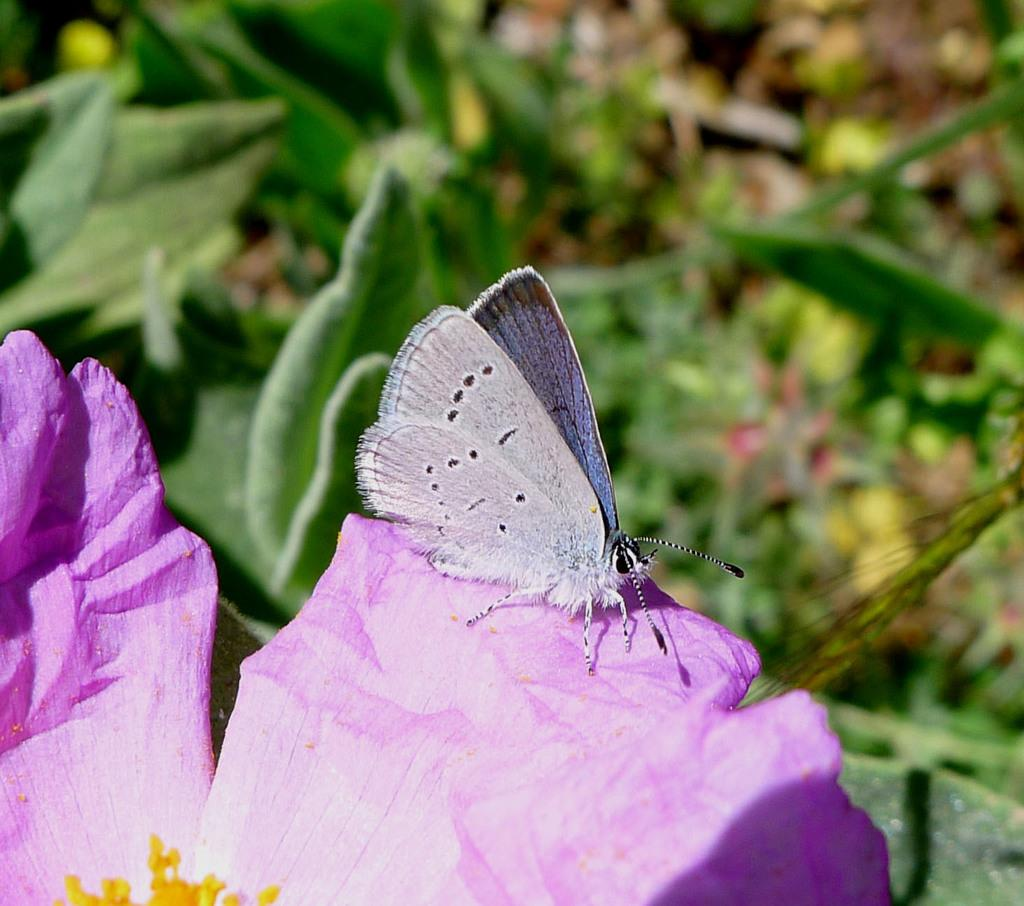What is the main subject of the image? There is a butterfly in the image. Where is the butterfly located? The butterfly is on a pink flower. What else can be seen in the image besides the butterfly? There are other plants in the image. How would you describe the quality of the image? The image is blurry to some extent. What type of property does the butterfly own in the image? There is no indication in the image that the butterfly owns any property. Can you tell me how many lakes are visible in the image? There are no lakes present in the image; it features a butterfly on a pink flower and other plants. 